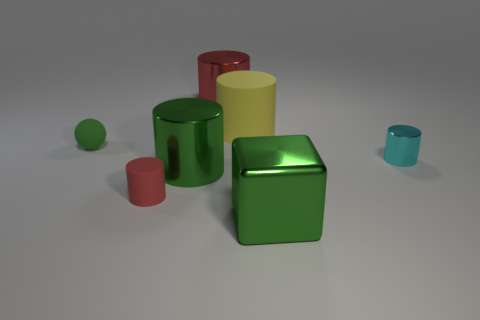What number of objects are the same color as the tiny rubber ball?
Your answer should be very brief. 2. Does the red thing that is behind the tiny cyan metallic cylinder have the same size as the metal cylinder that is to the right of the metal block?
Make the answer very short. No. How many things are small cylinders that are on the right side of the green cylinder or yellow matte cylinders?
Ensure brevity in your answer.  2. What is the small cyan thing made of?
Provide a succinct answer. Metal. Do the green matte thing and the yellow rubber cylinder have the same size?
Your answer should be very brief. No. What number of spheres are either big rubber things or small cyan things?
Provide a short and direct response. 0. There is a thing that is left of the rubber cylinder in front of the yellow thing; what is its color?
Provide a succinct answer. Green. Are there fewer big green cylinders that are behind the tiny metal cylinder than big cylinders in front of the red metallic object?
Ensure brevity in your answer.  Yes. Is the size of the red metallic cylinder the same as the cylinder that is to the right of the cube?
Your response must be concise. No. The green object that is both behind the green metallic block and in front of the tiny green rubber sphere has what shape?
Make the answer very short. Cylinder. 